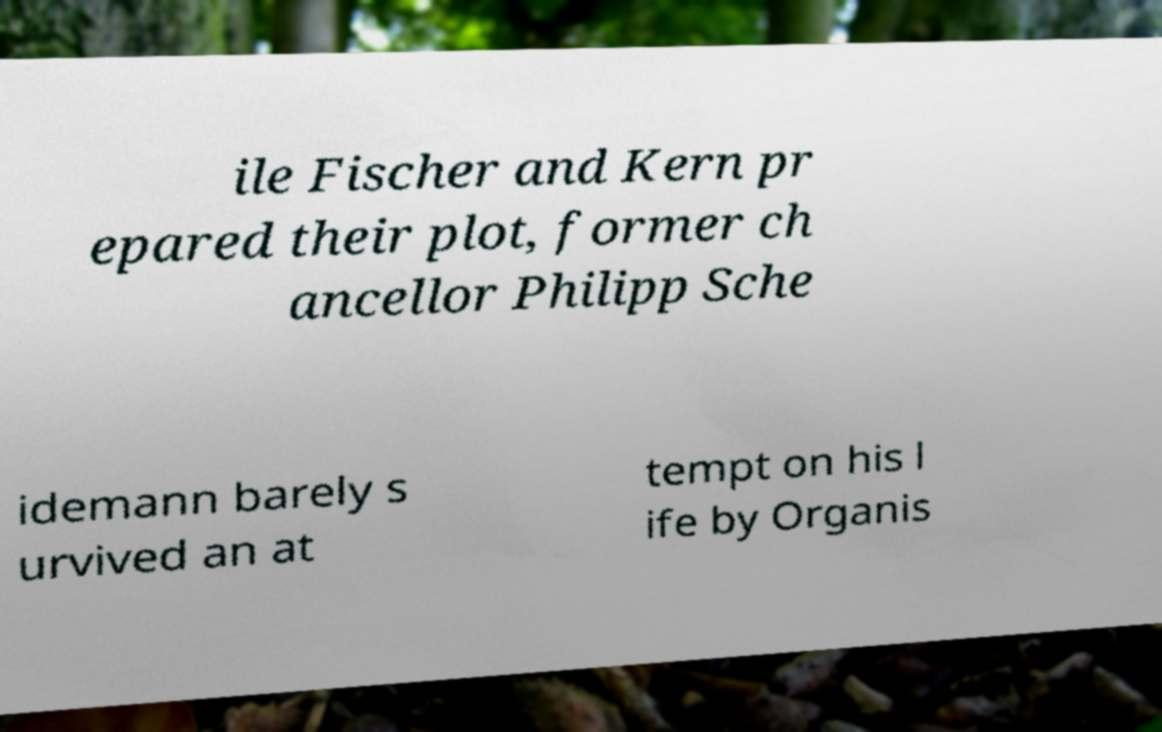Could you assist in decoding the text presented in this image and type it out clearly? ile Fischer and Kern pr epared their plot, former ch ancellor Philipp Sche idemann barely s urvived an at tempt on his l ife by Organis 